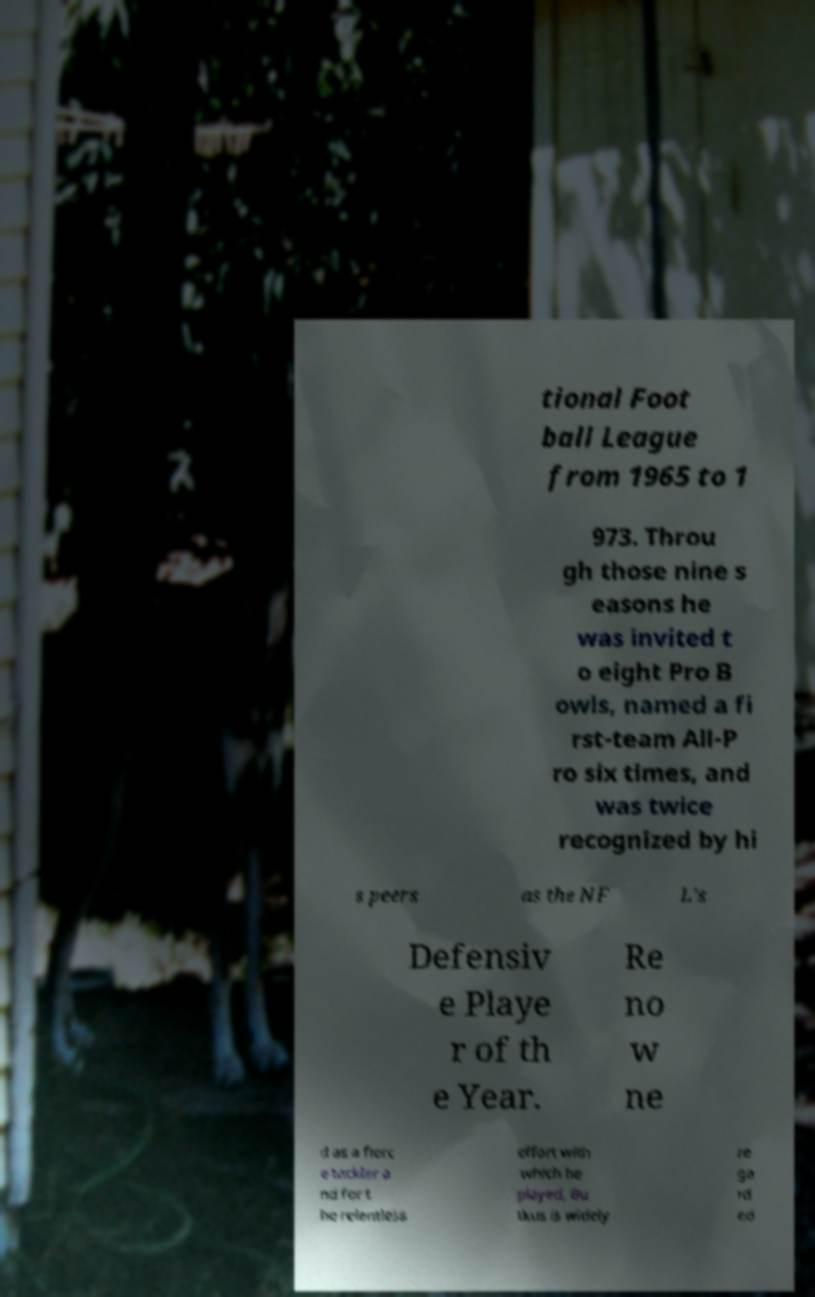For documentation purposes, I need the text within this image transcribed. Could you provide that? tional Foot ball League from 1965 to 1 973. Throu gh those nine s easons he was invited t o eight Pro B owls, named a fi rst-team All-P ro six times, and was twice recognized by hi s peers as the NF L's Defensiv e Playe r of th e Year. Re no w ne d as a fierc e tackler a nd for t he relentless effort with which he played, Bu tkus is widely re ga rd ed 